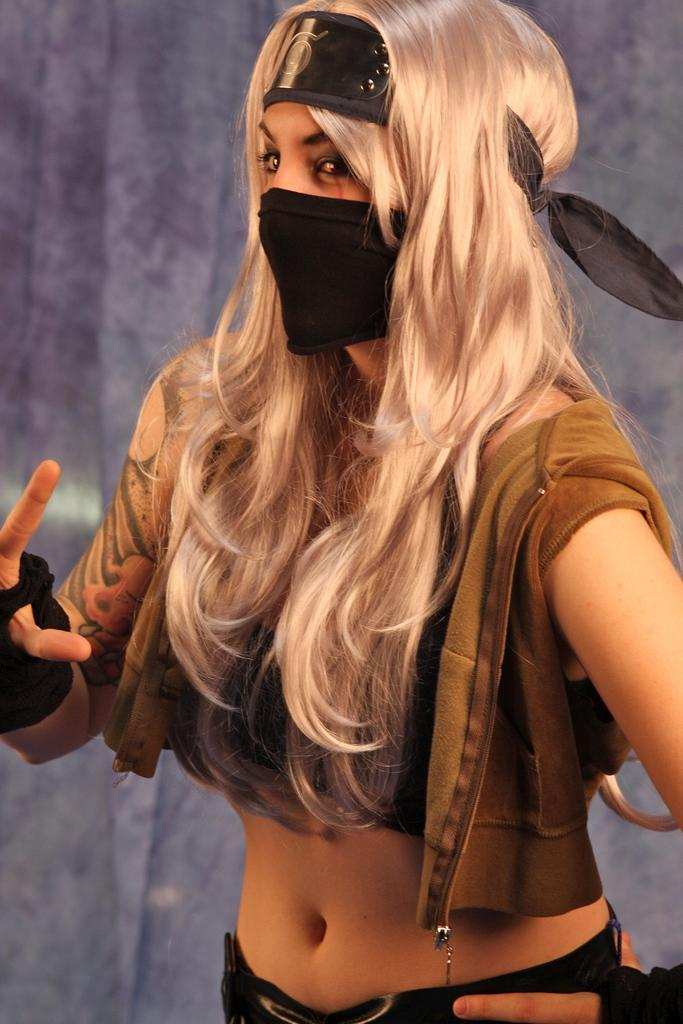Who is present in the image? There is a woman in the image. What is the woman doing in the image? The woman is standing over a place. What protective gear is the woman wearing? The woman is wearing gloves and a mask covering her mouth. What can be seen in the background of the image? There is a curtain visible in the image. What route is the pest taking to cross the boundary in the image? There is no pest or boundary present in the image; it features a woman standing over a place while wearing gloves and a mask. 